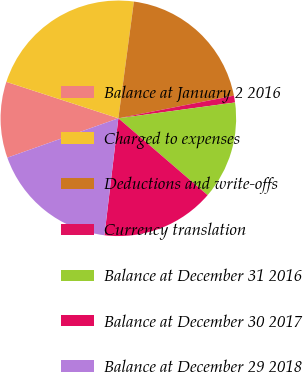Convert chart. <chart><loc_0><loc_0><loc_500><loc_500><pie_chart><fcel>Balance at January 2 2016<fcel>Charged to expenses<fcel>Deductions and write-offs<fcel>Currency translation<fcel>Balance at December 31 2016<fcel>Balance at December 30 2017<fcel>Balance at December 29 2018<nl><fcel>10.43%<fcel>22.1%<fcel>19.81%<fcel>0.94%<fcel>13.46%<fcel>15.57%<fcel>17.69%<nl></chart> 